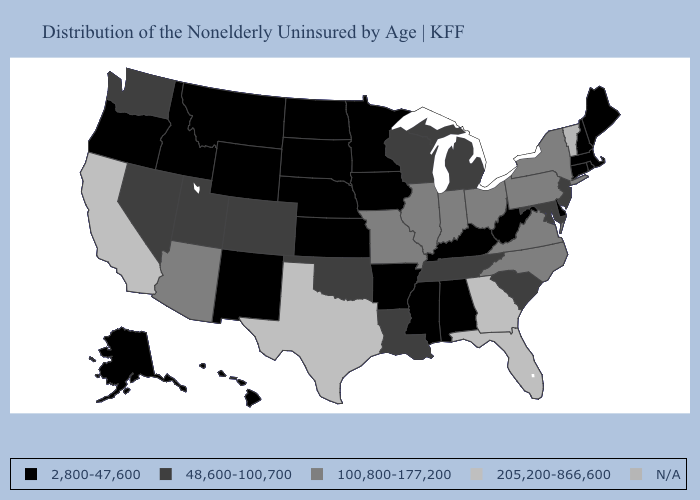Name the states that have a value in the range 100,800-177,200?
Concise answer only. Arizona, Illinois, Indiana, Missouri, New York, North Carolina, Ohio, Pennsylvania, Virginia. What is the highest value in states that border Tennessee?
Give a very brief answer. 205,200-866,600. Among the states that border Oklahoma , does Texas have the highest value?
Short answer required. Yes. Does Texas have the highest value in the USA?
Give a very brief answer. Yes. Is the legend a continuous bar?
Concise answer only. No. Does Texas have the highest value in the USA?
Concise answer only. Yes. Does Delaware have the highest value in the USA?
Concise answer only. No. Which states hav the highest value in the West?
Short answer required. California. Among the states that border Michigan , does Wisconsin have the lowest value?
Be succinct. Yes. Name the states that have a value in the range 48,600-100,700?
Keep it brief. Colorado, Louisiana, Maryland, Michigan, Nevada, New Jersey, Oklahoma, South Carolina, Tennessee, Utah, Washington, Wisconsin. Name the states that have a value in the range 100,800-177,200?
Quick response, please. Arizona, Illinois, Indiana, Missouri, New York, North Carolina, Ohio, Pennsylvania, Virginia. Among the states that border Delaware , which have the highest value?
Be succinct. Pennsylvania. Which states have the lowest value in the MidWest?
Short answer required. Iowa, Kansas, Minnesota, Nebraska, North Dakota, South Dakota. Does the first symbol in the legend represent the smallest category?
Quick response, please. Yes. 